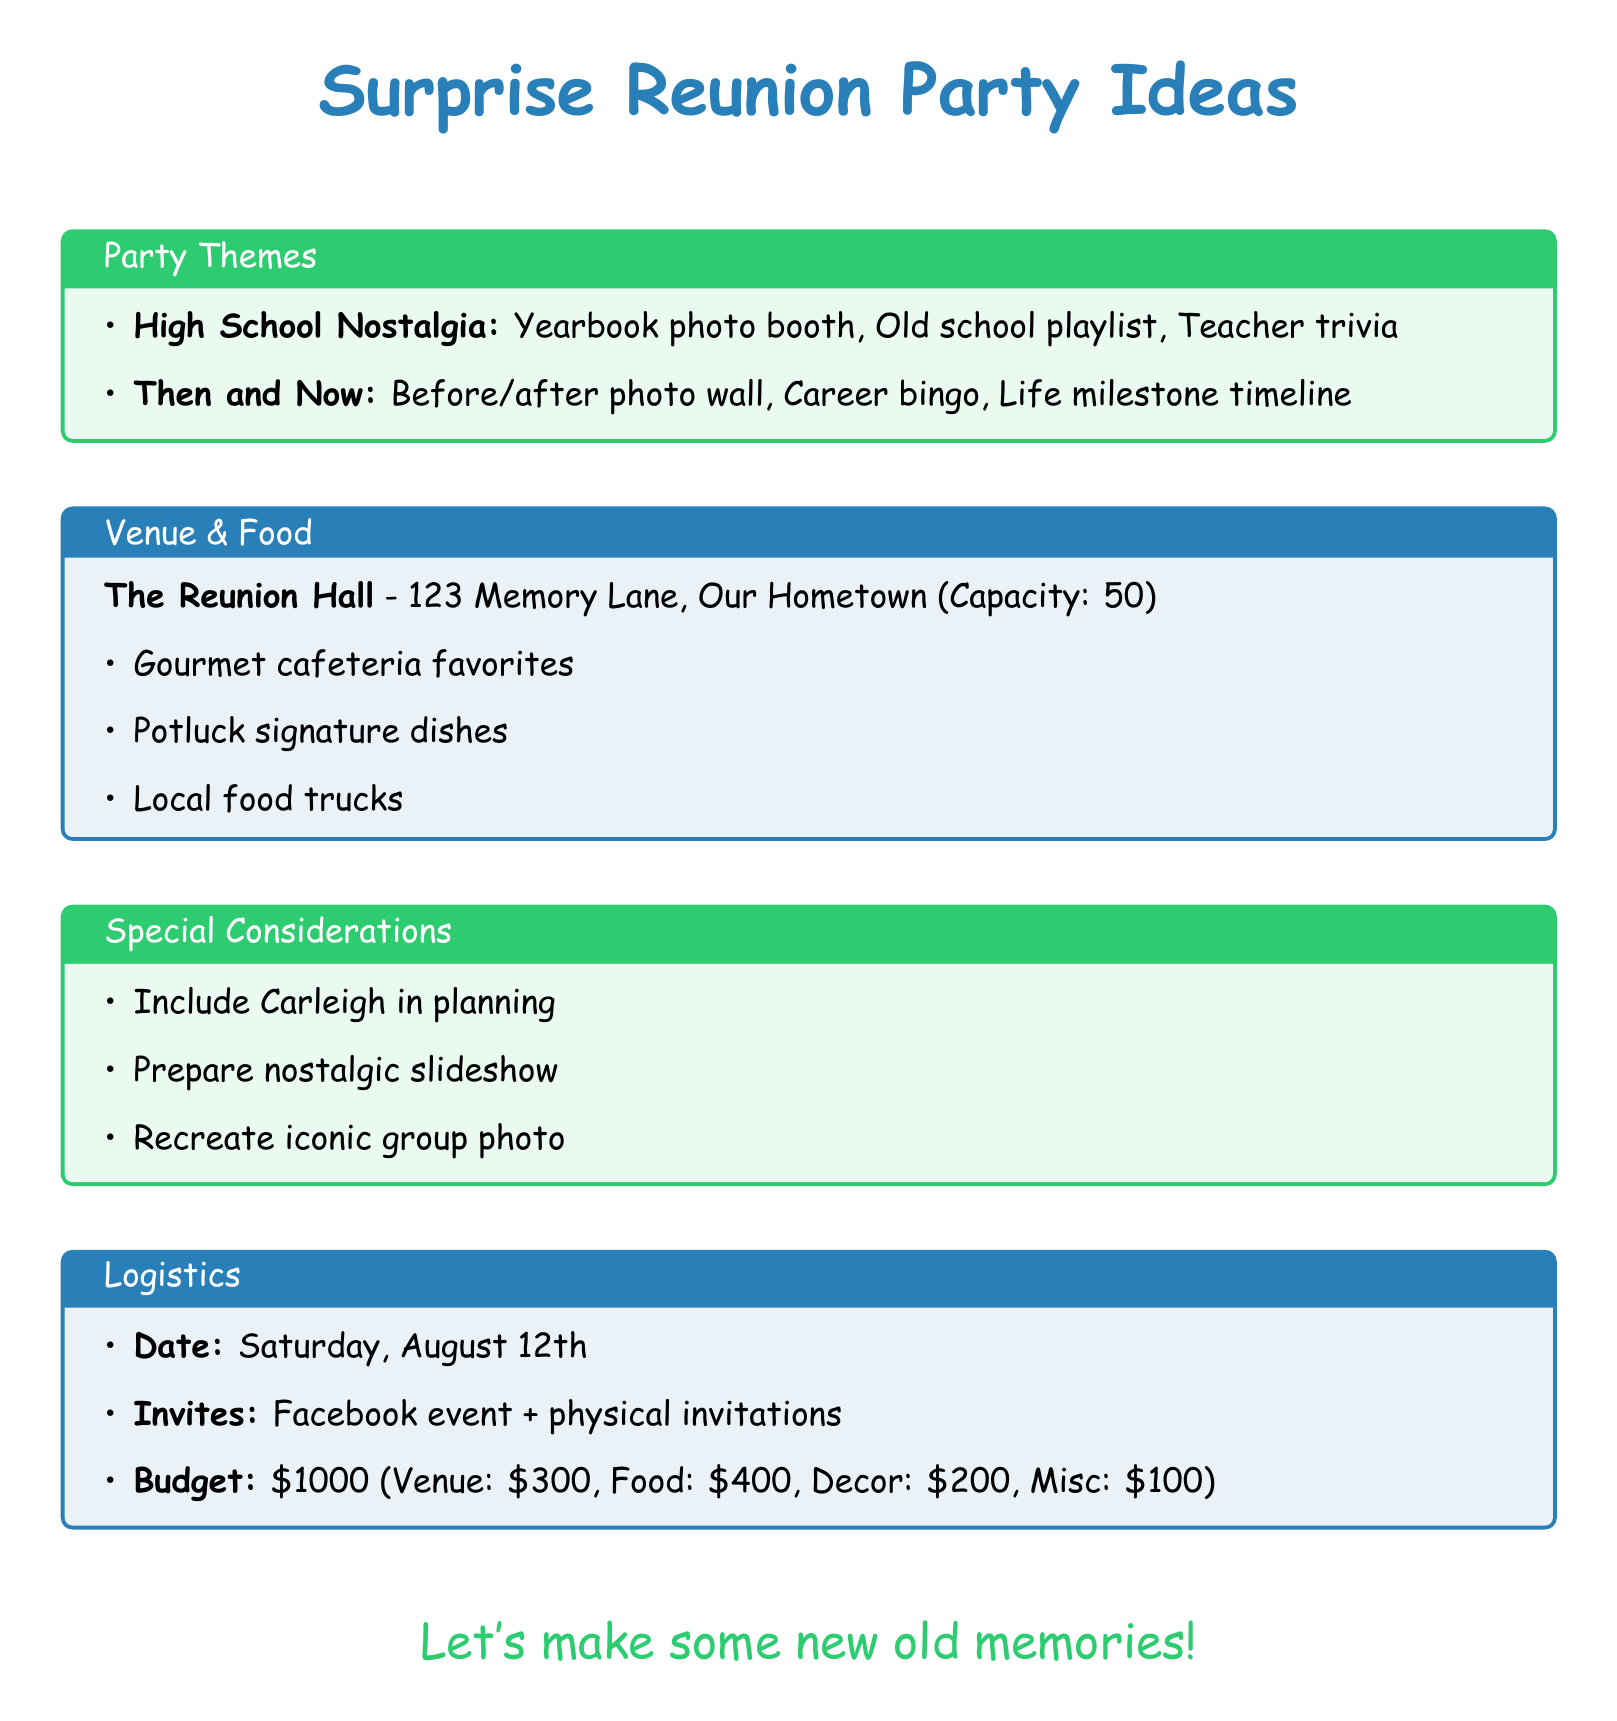what is the venue name? The venue name is specified in the document, which is "The Reunion Hall."
Answer: The Reunion Hall what is the estimated budget? The estimated total budget is found in the budget section, which is $1000.
Answer: $1000 what is one activity for the "High School Nostalgia" theme? This theme includes various activities, one of which is "Yearbook photo booth."
Answer: Yearbook photo booth who should be included in the planning process? The document mentions that Carleigh DeWald should be included in the planning for personal touches.
Answer: Carleigh DeWald when is the potential date for the reunion? The document clearly states that the potential date for the reunion is "Saturday, August 12th."
Answer: Saturday, August 12th what is one food idea mentioned? There are several food ideas listed, one of which is "Gourmet cafeteria favorites."
Answer: Gourmet cafeteria favorites what is one method of invitation? The primary method of invitation mentioned is to "Create a private Facebook event."
Answer: Create a private Facebook event how many guests can the venue accommodate? The capacity of the venue is specified in the venue section as 50.
Answer: 50 